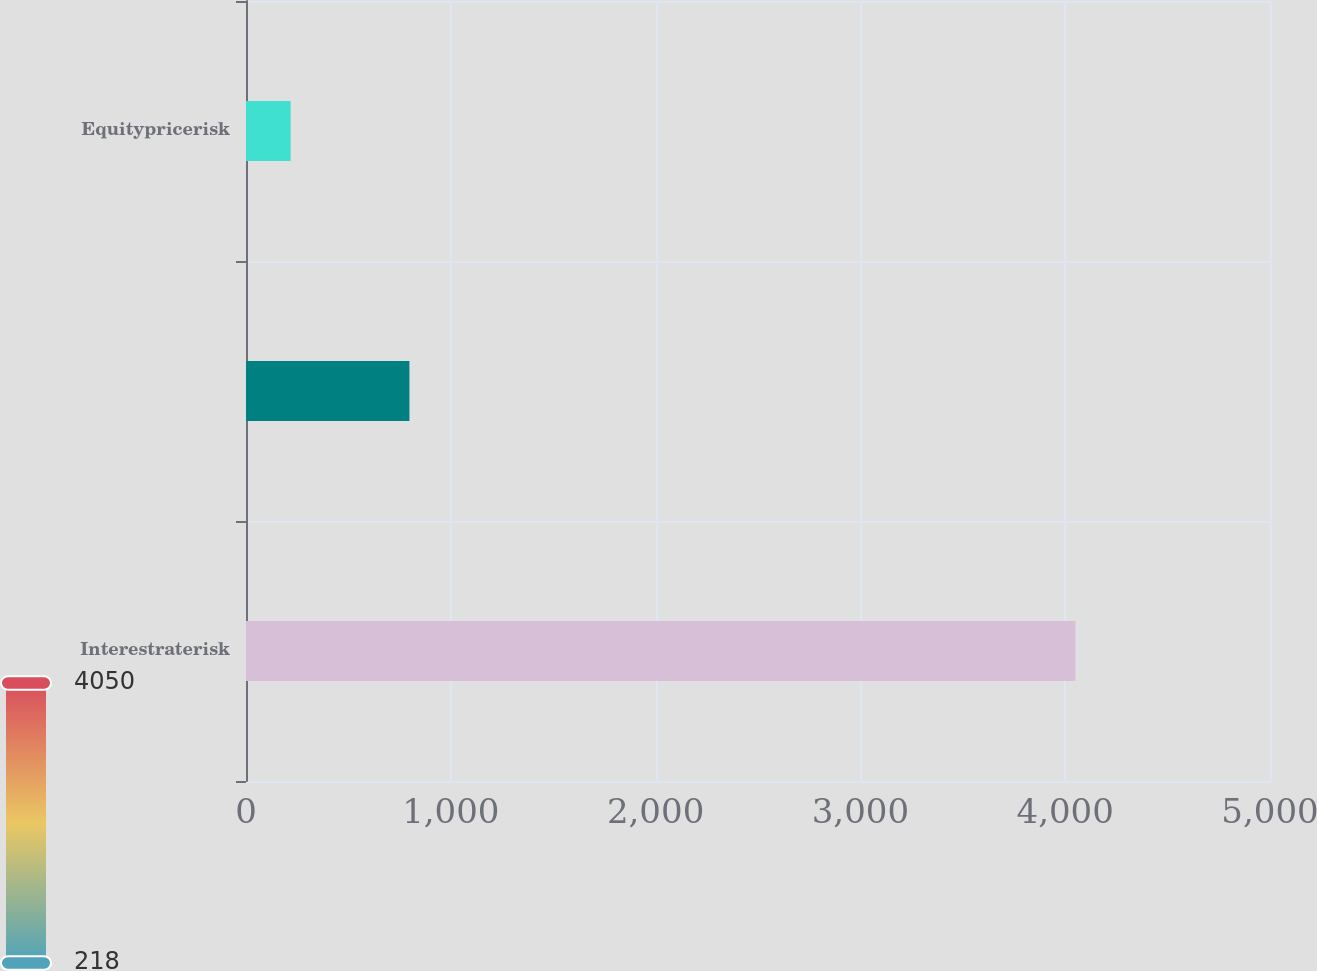Convert chart. <chart><loc_0><loc_0><loc_500><loc_500><bar_chart><fcel>Interestraterisk<fcel>Unnamed: 1<fcel>Equitypricerisk<nl><fcel>4050<fcel>798<fcel>218<nl></chart> 